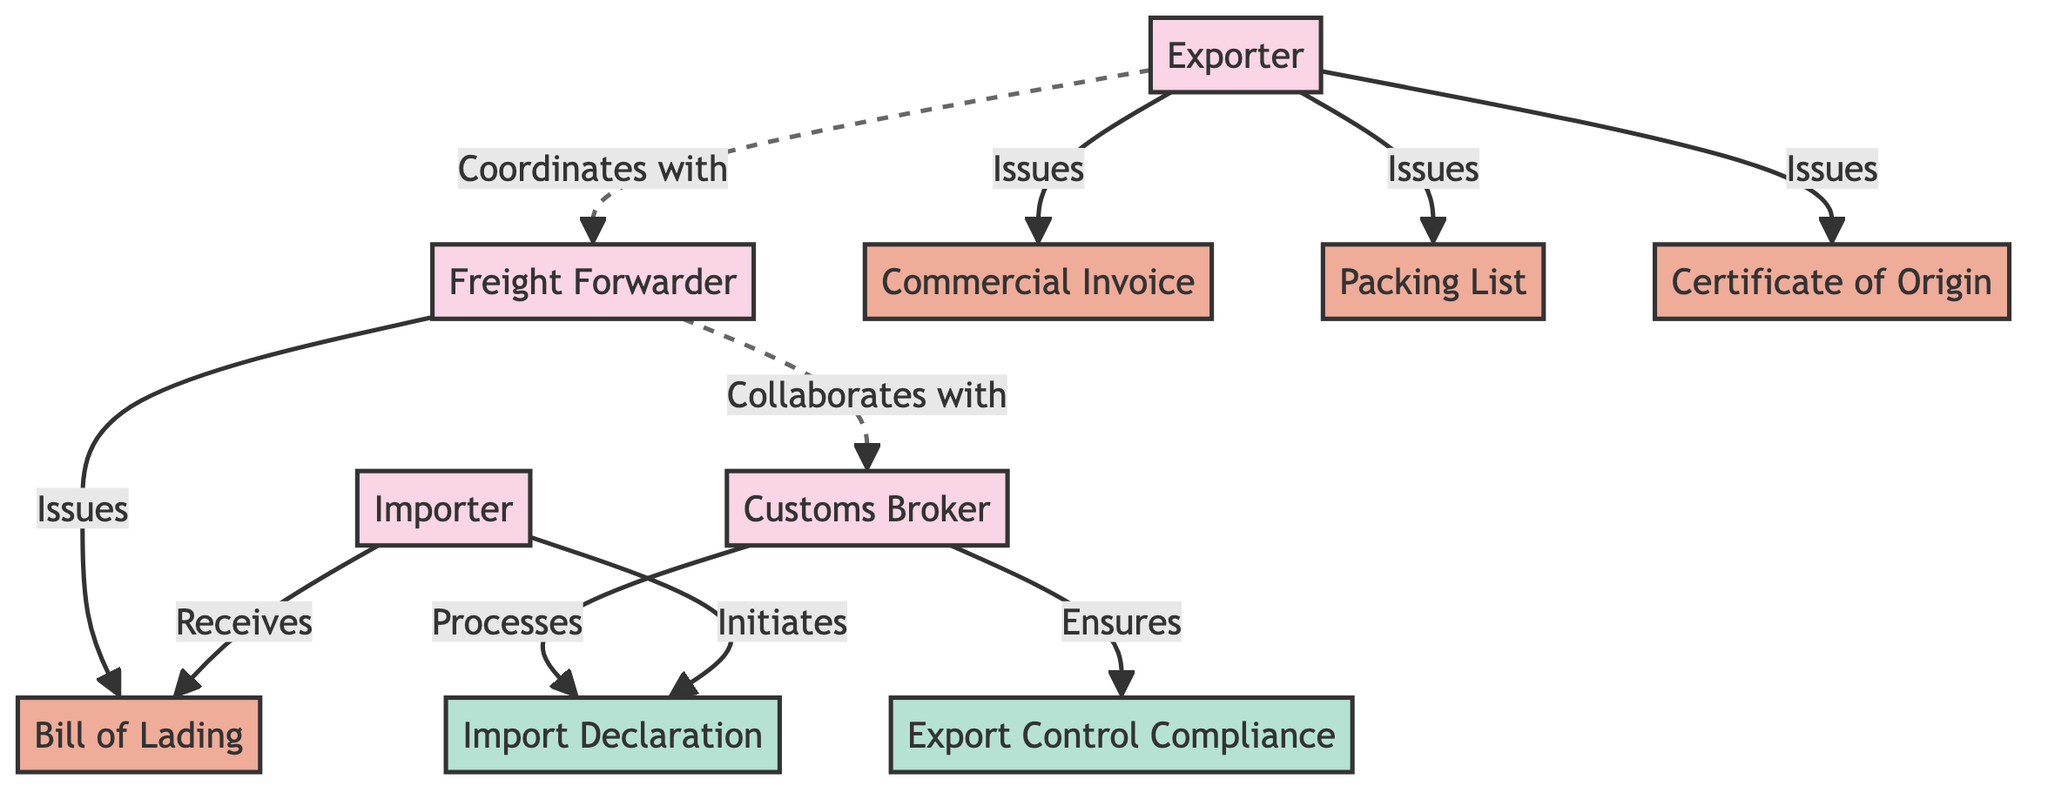What is the total number of entities in the diagram? There are four entities: Exporter, Importer, Freight Forwarder, and Customs Broker. To find the total, simply count the entities listed.
Answer: 4 Which document is issued by the Exporter? The Exporter issues the Commercial Invoice, Packing List, and Certificate of Origin, but the question asks specifically for the document issued by the Exporter. The primary document in this context is the Commercial Invoice.
Answer: Commercial Invoice Who does the Importer initiate the process with? The Importer initiates the Import Declaration process. This is directly indicated by the edge connecting the Importer to the Import Declaration with the label "Initiates."
Answer: Import Declaration What type of relationship exists between the Freight Forwarder and the Customs Broker? The relationship between the Freight Forwarder and the Customs Broker is a collaborative one, as indicated by the "Collaborates with" label on the arrow connecting these two nodes.
Answer: Collaborates with How many documents does the Exporter issue? The Exporter issues three documents: Commercial Invoice, Packing List, and Certificate of Origin. This count can be ascertained by looking at all the outgoing edges from the Exporter node.
Answer: 3 What process does the Customs Broker ensure compliance with? The Customs Broker ensures compliance with Export Control Compliance. This is indicated by the arrow labeled "Ensures" connecting the Customs Broker to Export Control Compliance.
Answer: Export Control Compliance Which document does the Importer receive from the Freight Forwarder? The Importer receives the Bill of Lading from the Freight Forwarder. This is shown by the directed edge labeled "Receives" from the Importer to the Bill of Lading.
Answer: Bill of Lading What is the role of the Customs Broker in the workflow? The role of the Customs Broker is to ensure customs compliance and documentation accuracy, as represented in the description of the Customs Broker node.
Answer: Ensures customs compliance and documentation accuracy Which entity coordinates with the Freight Forwarder? The Exporter coordinates with the Freight Forwarder. This relationship is indicated by the dashed line labeled "Coordinates with" between the Exporter and Freight Forwarder.
Answer: Exporter 